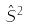<formula> <loc_0><loc_0><loc_500><loc_500>\hat { S } ^ { 2 }</formula> 